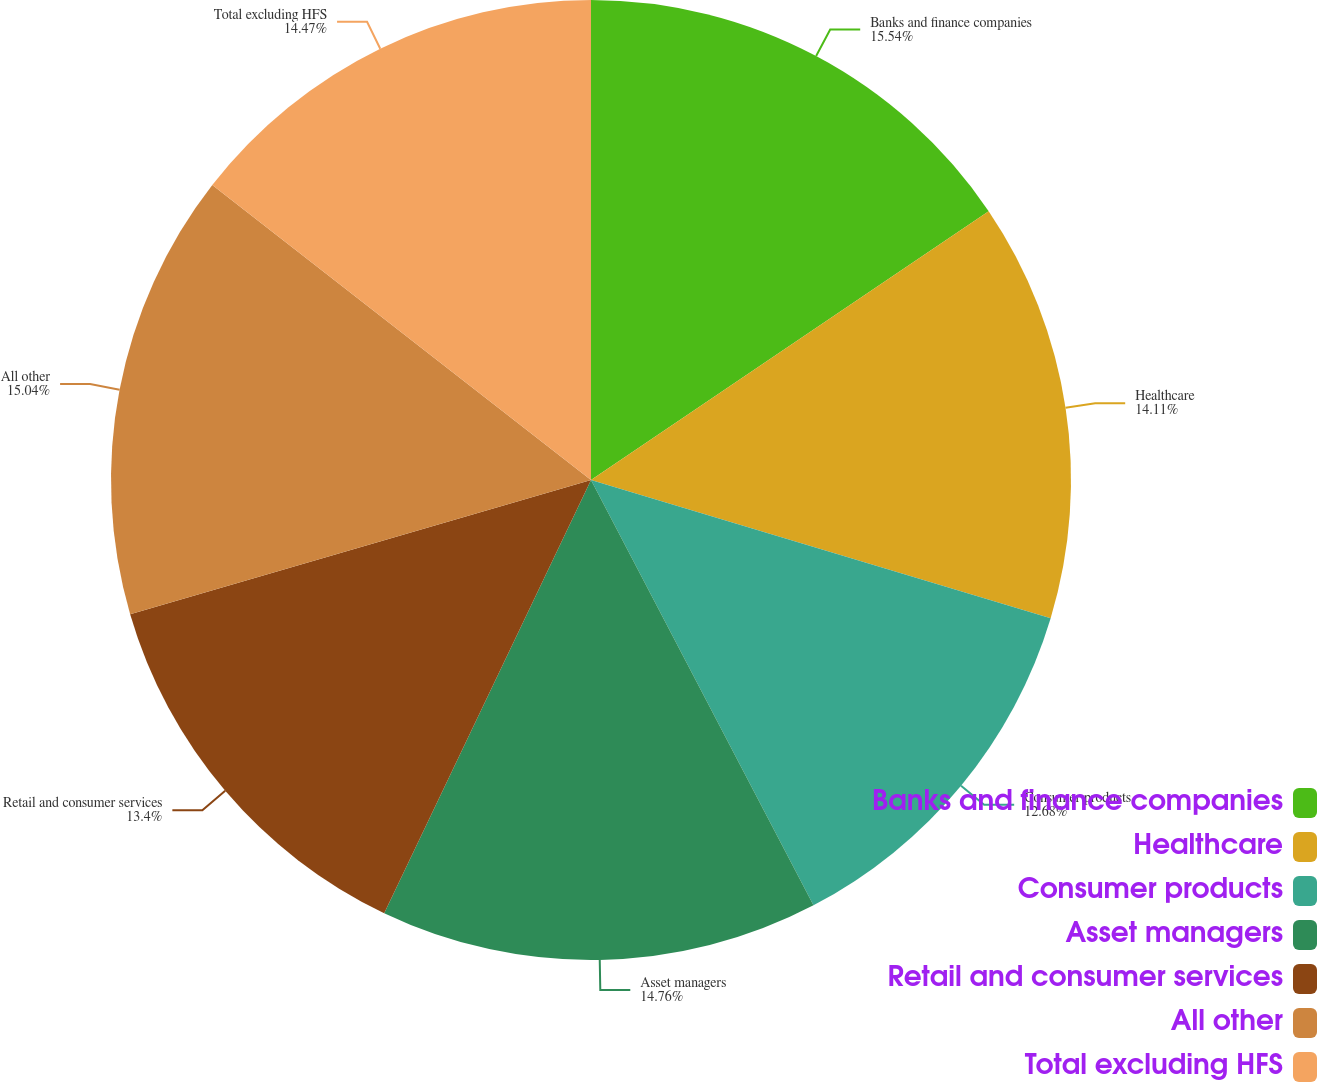Convert chart. <chart><loc_0><loc_0><loc_500><loc_500><pie_chart><fcel>Banks and finance companies<fcel>Healthcare<fcel>Consumer products<fcel>Asset managers<fcel>Retail and consumer services<fcel>All other<fcel>Total excluding HFS<nl><fcel>15.54%<fcel>14.11%<fcel>12.68%<fcel>14.76%<fcel>13.4%<fcel>15.04%<fcel>14.47%<nl></chart> 